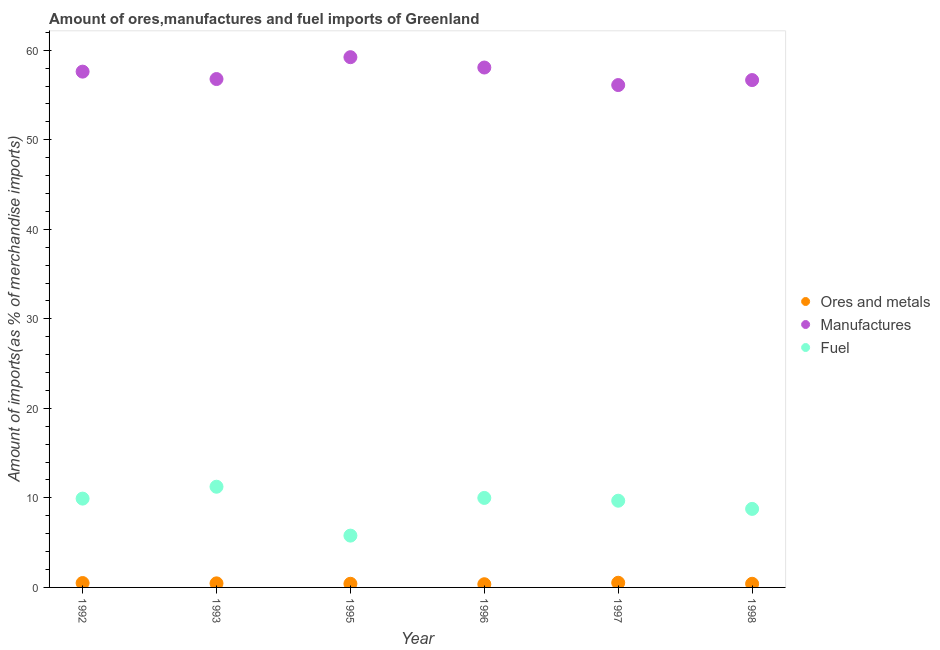How many different coloured dotlines are there?
Ensure brevity in your answer.  3. What is the percentage of fuel imports in 1998?
Your answer should be compact. 8.77. Across all years, what is the maximum percentage of manufactures imports?
Your answer should be very brief. 59.22. Across all years, what is the minimum percentage of fuel imports?
Make the answer very short. 5.79. In which year was the percentage of fuel imports maximum?
Ensure brevity in your answer.  1993. In which year was the percentage of ores and metals imports minimum?
Your response must be concise. 1996. What is the total percentage of ores and metals imports in the graph?
Your response must be concise. 2.64. What is the difference between the percentage of fuel imports in 1993 and that in 1997?
Offer a terse response. 1.56. What is the difference between the percentage of manufactures imports in 1993 and the percentage of ores and metals imports in 1996?
Your response must be concise. 56.42. What is the average percentage of ores and metals imports per year?
Provide a short and direct response. 0.44. In the year 1996, what is the difference between the percentage of manufactures imports and percentage of fuel imports?
Provide a succinct answer. 48.07. What is the ratio of the percentage of manufactures imports in 1995 to that in 1998?
Offer a terse response. 1.05. Is the difference between the percentage of ores and metals imports in 1992 and 1998 greater than the difference between the percentage of manufactures imports in 1992 and 1998?
Your response must be concise. No. What is the difference between the highest and the second highest percentage of fuel imports?
Make the answer very short. 1.25. What is the difference between the highest and the lowest percentage of fuel imports?
Your response must be concise. 5.46. Is it the case that in every year, the sum of the percentage of ores and metals imports and percentage of manufactures imports is greater than the percentage of fuel imports?
Your response must be concise. Yes. Is the percentage of ores and metals imports strictly greater than the percentage of manufactures imports over the years?
Offer a terse response. No. Is the percentage of manufactures imports strictly less than the percentage of fuel imports over the years?
Give a very brief answer. No. How many dotlines are there?
Make the answer very short. 3. Where does the legend appear in the graph?
Provide a short and direct response. Center right. How are the legend labels stacked?
Offer a terse response. Vertical. What is the title of the graph?
Offer a terse response. Amount of ores,manufactures and fuel imports of Greenland. What is the label or title of the Y-axis?
Offer a terse response. Amount of imports(as % of merchandise imports). What is the Amount of imports(as % of merchandise imports) of Ores and metals in 1992?
Offer a terse response. 0.49. What is the Amount of imports(as % of merchandise imports) of Manufactures in 1992?
Offer a terse response. 57.61. What is the Amount of imports(as % of merchandise imports) of Fuel in 1992?
Your response must be concise. 9.92. What is the Amount of imports(as % of merchandise imports) of Ores and metals in 1993?
Provide a short and direct response. 0.45. What is the Amount of imports(as % of merchandise imports) in Manufactures in 1993?
Your response must be concise. 56.78. What is the Amount of imports(as % of merchandise imports) in Fuel in 1993?
Give a very brief answer. 11.25. What is the Amount of imports(as % of merchandise imports) of Ores and metals in 1995?
Give a very brief answer. 0.41. What is the Amount of imports(as % of merchandise imports) of Manufactures in 1995?
Ensure brevity in your answer.  59.22. What is the Amount of imports(as % of merchandise imports) of Fuel in 1995?
Your answer should be compact. 5.79. What is the Amount of imports(as % of merchandise imports) in Ores and metals in 1996?
Keep it short and to the point. 0.36. What is the Amount of imports(as % of merchandise imports) in Manufactures in 1996?
Offer a very short reply. 58.07. What is the Amount of imports(as % of merchandise imports) in Fuel in 1996?
Provide a short and direct response. 10. What is the Amount of imports(as % of merchandise imports) of Ores and metals in 1997?
Your answer should be compact. 0.52. What is the Amount of imports(as % of merchandise imports) of Manufactures in 1997?
Your answer should be compact. 56.11. What is the Amount of imports(as % of merchandise imports) in Fuel in 1997?
Your response must be concise. 9.68. What is the Amount of imports(as % of merchandise imports) of Ores and metals in 1998?
Your response must be concise. 0.41. What is the Amount of imports(as % of merchandise imports) of Manufactures in 1998?
Ensure brevity in your answer.  56.67. What is the Amount of imports(as % of merchandise imports) in Fuel in 1998?
Your answer should be very brief. 8.77. Across all years, what is the maximum Amount of imports(as % of merchandise imports) of Ores and metals?
Provide a succinct answer. 0.52. Across all years, what is the maximum Amount of imports(as % of merchandise imports) of Manufactures?
Keep it short and to the point. 59.22. Across all years, what is the maximum Amount of imports(as % of merchandise imports) in Fuel?
Ensure brevity in your answer.  11.25. Across all years, what is the minimum Amount of imports(as % of merchandise imports) of Ores and metals?
Offer a terse response. 0.36. Across all years, what is the minimum Amount of imports(as % of merchandise imports) of Manufactures?
Your answer should be very brief. 56.11. Across all years, what is the minimum Amount of imports(as % of merchandise imports) of Fuel?
Your answer should be compact. 5.79. What is the total Amount of imports(as % of merchandise imports) of Ores and metals in the graph?
Your response must be concise. 2.64. What is the total Amount of imports(as % of merchandise imports) in Manufactures in the graph?
Provide a succinct answer. 344.45. What is the total Amount of imports(as % of merchandise imports) of Fuel in the graph?
Your answer should be very brief. 55.4. What is the difference between the Amount of imports(as % of merchandise imports) of Ores and metals in 1992 and that in 1993?
Your response must be concise. 0.04. What is the difference between the Amount of imports(as % of merchandise imports) of Manufactures in 1992 and that in 1993?
Give a very brief answer. 0.83. What is the difference between the Amount of imports(as % of merchandise imports) in Fuel in 1992 and that in 1993?
Your answer should be compact. -1.33. What is the difference between the Amount of imports(as % of merchandise imports) in Ores and metals in 1992 and that in 1995?
Give a very brief answer. 0.08. What is the difference between the Amount of imports(as % of merchandise imports) in Manufactures in 1992 and that in 1995?
Give a very brief answer. -1.61. What is the difference between the Amount of imports(as % of merchandise imports) of Fuel in 1992 and that in 1995?
Your answer should be compact. 4.13. What is the difference between the Amount of imports(as % of merchandise imports) in Ores and metals in 1992 and that in 1996?
Offer a very short reply. 0.13. What is the difference between the Amount of imports(as % of merchandise imports) of Manufactures in 1992 and that in 1996?
Provide a short and direct response. -0.46. What is the difference between the Amount of imports(as % of merchandise imports) of Fuel in 1992 and that in 1996?
Your answer should be very brief. -0.08. What is the difference between the Amount of imports(as % of merchandise imports) of Ores and metals in 1992 and that in 1997?
Make the answer very short. -0.03. What is the difference between the Amount of imports(as % of merchandise imports) in Manufactures in 1992 and that in 1997?
Ensure brevity in your answer.  1.5. What is the difference between the Amount of imports(as % of merchandise imports) of Fuel in 1992 and that in 1997?
Provide a short and direct response. 0.24. What is the difference between the Amount of imports(as % of merchandise imports) in Ores and metals in 1992 and that in 1998?
Offer a very short reply. 0.08. What is the difference between the Amount of imports(as % of merchandise imports) of Manufactures in 1992 and that in 1998?
Provide a short and direct response. 0.94. What is the difference between the Amount of imports(as % of merchandise imports) of Fuel in 1992 and that in 1998?
Your response must be concise. 1.15. What is the difference between the Amount of imports(as % of merchandise imports) of Ores and metals in 1993 and that in 1995?
Keep it short and to the point. 0.05. What is the difference between the Amount of imports(as % of merchandise imports) in Manufactures in 1993 and that in 1995?
Ensure brevity in your answer.  -2.44. What is the difference between the Amount of imports(as % of merchandise imports) in Fuel in 1993 and that in 1995?
Provide a succinct answer. 5.46. What is the difference between the Amount of imports(as % of merchandise imports) in Ores and metals in 1993 and that in 1996?
Offer a terse response. 0.1. What is the difference between the Amount of imports(as % of merchandise imports) in Manufactures in 1993 and that in 1996?
Your response must be concise. -1.29. What is the difference between the Amount of imports(as % of merchandise imports) of Fuel in 1993 and that in 1996?
Keep it short and to the point. 1.25. What is the difference between the Amount of imports(as % of merchandise imports) in Ores and metals in 1993 and that in 1997?
Your answer should be very brief. -0.07. What is the difference between the Amount of imports(as % of merchandise imports) in Manufactures in 1993 and that in 1997?
Your response must be concise. 0.67. What is the difference between the Amount of imports(as % of merchandise imports) in Fuel in 1993 and that in 1997?
Provide a succinct answer. 1.56. What is the difference between the Amount of imports(as % of merchandise imports) in Ores and metals in 1993 and that in 1998?
Your answer should be very brief. 0.05. What is the difference between the Amount of imports(as % of merchandise imports) of Manufactures in 1993 and that in 1998?
Keep it short and to the point. 0.12. What is the difference between the Amount of imports(as % of merchandise imports) in Fuel in 1993 and that in 1998?
Offer a very short reply. 2.48. What is the difference between the Amount of imports(as % of merchandise imports) of Ores and metals in 1995 and that in 1996?
Make the answer very short. 0.05. What is the difference between the Amount of imports(as % of merchandise imports) of Manufactures in 1995 and that in 1996?
Offer a very short reply. 1.16. What is the difference between the Amount of imports(as % of merchandise imports) in Fuel in 1995 and that in 1996?
Give a very brief answer. -4.21. What is the difference between the Amount of imports(as % of merchandise imports) of Ores and metals in 1995 and that in 1997?
Your answer should be very brief. -0.11. What is the difference between the Amount of imports(as % of merchandise imports) of Manufactures in 1995 and that in 1997?
Ensure brevity in your answer.  3.11. What is the difference between the Amount of imports(as % of merchandise imports) of Fuel in 1995 and that in 1997?
Make the answer very short. -3.9. What is the difference between the Amount of imports(as % of merchandise imports) of Ores and metals in 1995 and that in 1998?
Provide a succinct answer. 0. What is the difference between the Amount of imports(as % of merchandise imports) in Manufactures in 1995 and that in 1998?
Offer a terse response. 2.56. What is the difference between the Amount of imports(as % of merchandise imports) of Fuel in 1995 and that in 1998?
Provide a short and direct response. -2.98. What is the difference between the Amount of imports(as % of merchandise imports) in Ores and metals in 1996 and that in 1997?
Provide a succinct answer. -0.16. What is the difference between the Amount of imports(as % of merchandise imports) in Manufactures in 1996 and that in 1997?
Your response must be concise. 1.96. What is the difference between the Amount of imports(as % of merchandise imports) of Fuel in 1996 and that in 1997?
Your answer should be very brief. 0.31. What is the difference between the Amount of imports(as % of merchandise imports) of Ores and metals in 1996 and that in 1998?
Your answer should be compact. -0.05. What is the difference between the Amount of imports(as % of merchandise imports) in Manufactures in 1996 and that in 1998?
Ensure brevity in your answer.  1.4. What is the difference between the Amount of imports(as % of merchandise imports) of Fuel in 1996 and that in 1998?
Your answer should be compact. 1.23. What is the difference between the Amount of imports(as % of merchandise imports) in Ores and metals in 1997 and that in 1998?
Make the answer very short. 0.11. What is the difference between the Amount of imports(as % of merchandise imports) of Manufactures in 1997 and that in 1998?
Provide a short and direct response. -0.56. What is the difference between the Amount of imports(as % of merchandise imports) of Fuel in 1997 and that in 1998?
Give a very brief answer. 0.91. What is the difference between the Amount of imports(as % of merchandise imports) of Ores and metals in 1992 and the Amount of imports(as % of merchandise imports) of Manufactures in 1993?
Make the answer very short. -56.29. What is the difference between the Amount of imports(as % of merchandise imports) of Ores and metals in 1992 and the Amount of imports(as % of merchandise imports) of Fuel in 1993?
Provide a succinct answer. -10.76. What is the difference between the Amount of imports(as % of merchandise imports) of Manufactures in 1992 and the Amount of imports(as % of merchandise imports) of Fuel in 1993?
Ensure brevity in your answer.  46.36. What is the difference between the Amount of imports(as % of merchandise imports) in Ores and metals in 1992 and the Amount of imports(as % of merchandise imports) in Manufactures in 1995?
Your answer should be compact. -58.73. What is the difference between the Amount of imports(as % of merchandise imports) of Ores and metals in 1992 and the Amount of imports(as % of merchandise imports) of Fuel in 1995?
Give a very brief answer. -5.3. What is the difference between the Amount of imports(as % of merchandise imports) in Manufactures in 1992 and the Amount of imports(as % of merchandise imports) in Fuel in 1995?
Make the answer very short. 51.82. What is the difference between the Amount of imports(as % of merchandise imports) of Ores and metals in 1992 and the Amount of imports(as % of merchandise imports) of Manufactures in 1996?
Keep it short and to the point. -57.58. What is the difference between the Amount of imports(as % of merchandise imports) of Ores and metals in 1992 and the Amount of imports(as % of merchandise imports) of Fuel in 1996?
Your answer should be compact. -9.51. What is the difference between the Amount of imports(as % of merchandise imports) in Manufactures in 1992 and the Amount of imports(as % of merchandise imports) in Fuel in 1996?
Ensure brevity in your answer.  47.61. What is the difference between the Amount of imports(as % of merchandise imports) in Ores and metals in 1992 and the Amount of imports(as % of merchandise imports) in Manufactures in 1997?
Offer a very short reply. -55.62. What is the difference between the Amount of imports(as % of merchandise imports) in Ores and metals in 1992 and the Amount of imports(as % of merchandise imports) in Fuel in 1997?
Make the answer very short. -9.19. What is the difference between the Amount of imports(as % of merchandise imports) in Manufactures in 1992 and the Amount of imports(as % of merchandise imports) in Fuel in 1997?
Your answer should be very brief. 47.92. What is the difference between the Amount of imports(as % of merchandise imports) of Ores and metals in 1992 and the Amount of imports(as % of merchandise imports) of Manufactures in 1998?
Give a very brief answer. -56.17. What is the difference between the Amount of imports(as % of merchandise imports) in Ores and metals in 1992 and the Amount of imports(as % of merchandise imports) in Fuel in 1998?
Offer a terse response. -8.28. What is the difference between the Amount of imports(as % of merchandise imports) in Manufactures in 1992 and the Amount of imports(as % of merchandise imports) in Fuel in 1998?
Ensure brevity in your answer.  48.84. What is the difference between the Amount of imports(as % of merchandise imports) in Ores and metals in 1993 and the Amount of imports(as % of merchandise imports) in Manufactures in 1995?
Provide a succinct answer. -58.77. What is the difference between the Amount of imports(as % of merchandise imports) in Ores and metals in 1993 and the Amount of imports(as % of merchandise imports) in Fuel in 1995?
Ensure brevity in your answer.  -5.33. What is the difference between the Amount of imports(as % of merchandise imports) in Manufactures in 1993 and the Amount of imports(as % of merchandise imports) in Fuel in 1995?
Your answer should be very brief. 50.99. What is the difference between the Amount of imports(as % of merchandise imports) in Ores and metals in 1993 and the Amount of imports(as % of merchandise imports) in Manufactures in 1996?
Ensure brevity in your answer.  -57.61. What is the difference between the Amount of imports(as % of merchandise imports) in Ores and metals in 1993 and the Amount of imports(as % of merchandise imports) in Fuel in 1996?
Ensure brevity in your answer.  -9.54. What is the difference between the Amount of imports(as % of merchandise imports) of Manufactures in 1993 and the Amount of imports(as % of merchandise imports) of Fuel in 1996?
Make the answer very short. 46.78. What is the difference between the Amount of imports(as % of merchandise imports) of Ores and metals in 1993 and the Amount of imports(as % of merchandise imports) of Manufactures in 1997?
Ensure brevity in your answer.  -55.65. What is the difference between the Amount of imports(as % of merchandise imports) of Ores and metals in 1993 and the Amount of imports(as % of merchandise imports) of Fuel in 1997?
Provide a succinct answer. -9.23. What is the difference between the Amount of imports(as % of merchandise imports) in Manufactures in 1993 and the Amount of imports(as % of merchandise imports) in Fuel in 1997?
Provide a succinct answer. 47.1. What is the difference between the Amount of imports(as % of merchandise imports) of Ores and metals in 1993 and the Amount of imports(as % of merchandise imports) of Manufactures in 1998?
Provide a short and direct response. -56.21. What is the difference between the Amount of imports(as % of merchandise imports) of Ores and metals in 1993 and the Amount of imports(as % of merchandise imports) of Fuel in 1998?
Your response must be concise. -8.32. What is the difference between the Amount of imports(as % of merchandise imports) of Manufactures in 1993 and the Amount of imports(as % of merchandise imports) of Fuel in 1998?
Your response must be concise. 48.01. What is the difference between the Amount of imports(as % of merchandise imports) in Ores and metals in 1995 and the Amount of imports(as % of merchandise imports) in Manufactures in 1996?
Your response must be concise. -57.66. What is the difference between the Amount of imports(as % of merchandise imports) of Ores and metals in 1995 and the Amount of imports(as % of merchandise imports) of Fuel in 1996?
Offer a terse response. -9.59. What is the difference between the Amount of imports(as % of merchandise imports) in Manufactures in 1995 and the Amount of imports(as % of merchandise imports) in Fuel in 1996?
Make the answer very short. 49.23. What is the difference between the Amount of imports(as % of merchandise imports) in Ores and metals in 1995 and the Amount of imports(as % of merchandise imports) in Manufactures in 1997?
Your answer should be compact. -55.7. What is the difference between the Amount of imports(as % of merchandise imports) in Ores and metals in 1995 and the Amount of imports(as % of merchandise imports) in Fuel in 1997?
Keep it short and to the point. -9.28. What is the difference between the Amount of imports(as % of merchandise imports) of Manufactures in 1995 and the Amount of imports(as % of merchandise imports) of Fuel in 1997?
Offer a very short reply. 49.54. What is the difference between the Amount of imports(as % of merchandise imports) in Ores and metals in 1995 and the Amount of imports(as % of merchandise imports) in Manufactures in 1998?
Your response must be concise. -56.26. What is the difference between the Amount of imports(as % of merchandise imports) in Ores and metals in 1995 and the Amount of imports(as % of merchandise imports) in Fuel in 1998?
Your answer should be compact. -8.36. What is the difference between the Amount of imports(as % of merchandise imports) of Manufactures in 1995 and the Amount of imports(as % of merchandise imports) of Fuel in 1998?
Your answer should be compact. 50.45. What is the difference between the Amount of imports(as % of merchandise imports) in Ores and metals in 1996 and the Amount of imports(as % of merchandise imports) in Manufactures in 1997?
Provide a short and direct response. -55.75. What is the difference between the Amount of imports(as % of merchandise imports) of Ores and metals in 1996 and the Amount of imports(as % of merchandise imports) of Fuel in 1997?
Offer a terse response. -9.33. What is the difference between the Amount of imports(as % of merchandise imports) of Manufactures in 1996 and the Amount of imports(as % of merchandise imports) of Fuel in 1997?
Your answer should be very brief. 48.38. What is the difference between the Amount of imports(as % of merchandise imports) in Ores and metals in 1996 and the Amount of imports(as % of merchandise imports) in Manufactures in 1998?
Your answer should be compact. -56.31. What is the difference between the Amount of imports(as % of merchandise imports) in Ores and metals in 1996 and the Amount of imports(as % of merchandise imports) in Fuel in 1998?
Your response must be concise. -8.41. What is the difference between the Amount of imports(as % of merchandise imports) in Manufactures in 1996 and the Amount of imports(as % of merchandise imports) in Fuel in 1998?
Your answer should be very brief. 49.3. What is the difference between the Amount of imports(as % of merchandise imports) of Ores and metals in 1997 and the Amount of imports(as % of merchandise imports) of Manufactures in 1998?
Your answer should be compact. -56.14. What is the difference between the Amount of imports(as % of merchandise imports) of Ores and metals in 1997 and the Amount of imports(as % of merchandise imports) of Fuel in 1998?
Offer a terse response. -8.25. What is the difference between the Amount of imports(as % of merchandise imports) of Manufactures in 1997 and the Amount of imports(as % of merchandise imports) of Fuel in 1998?
Give a very brief answer. 47.34. What is the average Amount of imports(as % of merchandise imports) of Ores and metals per year?
Make the answer very short. 0.44. What is the average Amount of imports(as % of merchandise imports) in Manufactures per year?
Keep it short and to the point. 57.41. What is the average Amount of imports(as % of merchandise imports) of Fuel per year?
Offer a terse response. 9.23. In the year 1992, what is the difference between the Amount of imports(as % of merchandise imports) in Ores and metals and Amount of imports(as % of merchandise imports) in Manufactures?
Offer a terse response. -57.12. In the year 1992, what is the difference between the Amount of imports(as % of merchandise imports) in Ores and metals and Amount of imports(as % of merchandise imports) in Fuel?
Make the answer very short. -9.43. In the year 1992, what is the difference between the Amount of imports(as % of merchandise imports) of Manufactures and Amount of imports(as % of merchandise imports) of Fuel?
Offer a terse response. 47.69. In the year 1993, what is the difference between the Amount of imports(as % of merchandise imports) in Ores and metals and Amount of imports(as % of merchandise imports) in Manufactures?
Give a very brief answer. -56.33. In the year 1993, what is the difference between the Amount of imports(as % of merchandise imports) of Ores and metals and Amount of imports(as % of merchandise imports) of Fuel?
Your answer should be very brief. -10.79. In the year 1993, what is the difference between the Amount of imports(as % of merchandise imports) in Manufactures and Amount of imports(as % of merchandise imports) in Fuel?
Your answer should be compact. 45.53. In the year 1995, what is the difference between the Amount of imports(as % of merchandise imports) of Ores and metals and Amount of imports(as % of merchandise imports) of Manufactures?
Offer a very short reply. -58.81. In the year 1995, what is the difference between the Amount of imports(as % of merchandise imports) in Ores and metals and Amount of imports(as % of merchandise imports) in Fuel?
Make the answer very short. -5.38. In the year 1995, what is the difference between the Amount of imports(as % of merchandise imports) in Manufactures and Amount of imports(as % of merchandise imports) in Fuel?
Ensure brevity in your answer.  53.44. In the year 1996, what is the difference between the Amount of imports(as % of merchandise imports) of Ores and metals and Amount of imports(as % of merchandise imports) of Manufactures?
Make the answer very short. -57.71. In the year 1996, what is the difference between the Amount of imports(as % of merchandise imports) of Ores and metals and Amount of imports(as % of merchandise imports) of Fuel?
Your answer should be very brief. -9.64. In the year 1996, what is the difference between the Amount of imports(as % of merchandise imports) of Manufactures and Amount of imports(as % of merchandise imports) of Fuel?
Your answer should be very brief. 48.07. In the year 1997, what is the difference between the Amount of imports(as % of merchandise imports) in Ores and metals and Amount of imports(as % of merchandise imports) in Manufactures?
Your answer should be compact. -55.59. In the year 1997, what is the difference between the Amount of imports(as % of merchandise imports) in Ores and metals and Amount of imports(as % of merchandise imports) in Fuel?
Your response must be concise. -9.16. In the year 1997, what is the difference between the Amount of imports(as % of merchandise imports) in Manufactures and Amount of imports(as % of merchandise imports) in Fuel?
Provide a short and direct response. 46.42. In the year 1998, what is the difference between the Amount of imports(as % of merchandise imports) of Ores and metals and Amount of imports(as % of merchandise imports) of Manufactures?
Offer a terse response. -56.26. In the year 1998, what is the difference between the Amount of imports(as % of merchandise imports) in Ores and metals and Amount of imports(as % of merchandise imports) in Fuel?
Your answer should be compact. -8.36. In the year 1998, what is the difference between the Amount of imports(as % of merchandise imports) in Manufactures and Amount of imports(as % of merchandise imports) in Fuel?
Your answer should be very brief. 47.89. What is the ratio of the Amount of imports(as % of merchandise imports) of Ores and metals in 1992 to that in 1993?
Your answer should be very brief. 1.08. What is the ratio of the Amount of imports(as % of merchandise imports) of Manufactures in 1992 to that in 1993?
Make the answer very short. 1.01. What is the ratio of the Amount of imports(as % of merchandise imports) in Fuel in 1992 to that in 1993?
Keep it short and to the point. 0.88. What is the ratio of the Amount of imports(as % of merchandise imports) in Ores and metals in 1992 to that in 1995?
Your response must be concise. 1.2. What is the ratio of the Amount of imports(as % of merchandise imports) in Manufactures in 1992 to that in 1995?
Provide a succinct answer. 0.97. What is the ratio of the Amount of imports(as % of merchandise imports) of Fuel in 1992 to that in 1995?
Give a very brief answer. 1.71. What is the ratio of the Amount of imports(as % of merchandise imports) of Ores and metals in 1992 to that in 1996?
Offer a very short reply. 1.37. What is the ratio of the Amount of imports(as % of merchandise imports) in Fuel in 1992 to that in 1996?
Provide a succinct answer. 0.99. What is the ratio of the Amount of imports(as % of merchandise imports) in Ores and metals in 1992 to that in 1997?
Your answer should be very brief. 0.94. What is the ratio of the Amount of imports(as % of merchandise imports) in Manufactures in 1992 to that in 1997?
Ensure brevity in your answer.  1.03. What is the ratio of the Amount of imports(as % of merchandise imports) in Fuel in 1992 to that in 1997?
Your answer should be very brief. 1.02. What is the ratio of the Amount of imports(as % of merchandise imports) of Ores and metals in 1992 to that in 1998?
Offer a terse response. 1.21. What is the ratio of the Amount of imports(as % of merchandise imports) of Manufactures in 1992 to that in 1998?
Provide a succinct answer. 1.02. What is the ratio of the Amount of imports(as % of merchandise imports) of Fuel in 1992 to that in 1998?
Provide a succinct answer. 1.13. What is the ratio of the Amount of imports(as % of merchandise imports) in Ores and metals in 1993 to that in 1995?
Provide a succinct answer. 1.11. What is the ratio of the Amount of imports(as % of merchandise imports) in Manufactures in 1993 to that in 1995?
Provide a succinct answer. 0.96. What is the ratio of the Amount of imports(as % of merchandise imports) in Fuel in 1993 to that in 1995?
Your response must be concise. 1.94. What is the ratio of the Amount of imports(as % of merchandise imports) in Ores and metals in 1993 to that in 1996?
Offer a very short reply. 1.27. What is the ratio of the Amount of imports(as % of merchandise imports) in Manufactures in 1993 to that in 1996?
Your answer should be very brief. 0.98. What is the ratio of the Amount of imports(as % of merchandise imports) in Fuel in 1993 to that in 1996?
Ensure brevity in your answer.  1.12. What is the ratio of the Amount of imports(as % of merchandise imports) in Ores and metals in 1993 to that in 1997?
Ensure brevity in your answer.  0.87. What is the ratio of the Amount of imports(as % of merchandise imports) in Fuel in 1993 to that in 1997?
Your answer should be compact. 1.16. What is the ratio of the Amount of imports(as % of merchandise imports) in Ores and metals in 1993 to that in 1998?
Your answer should be compact. 1.12. What is the ratio of the Amount of imports(as % of merchandise imports) in Fuel in 1993 to that in 1998?
Offer a terse response. 1.28. What is the ratio of the Amount of imports(as % of merchandise imports) of Ores and metals in 1995 to that in 1996?
Your answer should be compact. 1.14. What is the ratio of the Amount of imports(as % of merchandise imports) of Manufactures in 1995 to that in 1996?
Offer a very short reply. 1.02. What is the ratio of the Amount of imports(as % of merchandise imports) of Fuel in 1995 to that in 1996?
Offer a very short reply. 0.58. What is the ratio of the Amount of imports(as % of merchandise imports) of Ores and metals in 1995 to that in 1997?
Your answer should be compact. 0.78. What is the ratio of the Amount of imports(as % of merchandise imports) in Manufactures in 1995 to that in 1997?
Your answer should be very brief. 1.06. What is the ratio of the Amount of imports(as % of merchandise imports) of Fuel in 1995 to that in 1997?
Provide a short and direct response. 0.6. What is the ratio of the Amount of imports(as % of merchandise imports) of Ores and metals in 1995 to that in 1998?
Provide a short and direct response. 1. What is the ratio of the Amount of imports(as % of merchandise imports) in Manufactures in 1995 to that in 1998?
Your answer should be compact. 1.05. What is the ratio of the Amount of imports(as % of merchandise imports) of Fuel in 1995 to that in 1998?
Give a very brief answer. 0.66. What is the ratio of the Amount of imports(as % of merchandise imports) in Ores and metals in 1996 to that in 1997?
Your response must be concise. 0.69. What is the ratio of the Amount of imports(as % of merchandise imports) of Manufactures in 1996 to that in 1997?
Provide a succinct answer. 1.03. What is the ratio of the Amount of imports(as % of merchandise imports) of Fuel in 1996 to that in 1997?
Keep it short and to the point. 1.03. What is the ratio of the Amount of imports(as % of merchandise imports) in Ores and metals in 1996 to that in 1998?
Ensure brevity in your answer.  0.88. What is the ratio of the Amount of imports(as % of merchandise imports) in Manufactures in 1996 to that in 1998?
Your answer should be compact. 1.02. What is the ratio of the Amount of imports(as % of merchandise imports) in Fuel in 1996 to that in 1998?
Offer a terse response. 1.14. What is the ratio of the Amount of imports(as % of merchandise imports) of Ores and metals in 1997 to that in 1998?
Ensure brevity in your answer.  1.28. What is the ratio of the Amount of imports(as % of merchandise imports) of Manufactures in 1997 to that in 1998?
Ensure brevity in your answer.  0.99. What is the ratio of the Amount of imports(as % of merchandise imports) in Fuel in 1997 to that in 1998?
Offer a very short reply. 1.1. What is the difference between the highest and the second highest Amount of imports(as % of merchandise imports) of Ores and metals?
Offer a terse response. 0.03. What is the difference between the highest and the second highest Amount of imports(as % of merchandise imports) of Manufactures?
Provide a succinct answer. 1.16. What is the difference between the highest and the second highest Amount of imports(as % of merchandise imports) in Fuel?
Your answer should be very brief. 1.25. What is the difference between the highest and the lowest Amount of imports(as % of merchandise imports) of Ores and metals?
Give a very brief answer. 0.16. What is the difference between the highest and the lowest Amount of imports(as % of merchandise imports) in Manufactures?
Provide a short and direct response. 3.11. What is the difference between the highest and the lowest Amount of imports(as % of merchandise imports) of Fuel?
Your answer should be compact. 5.46. 